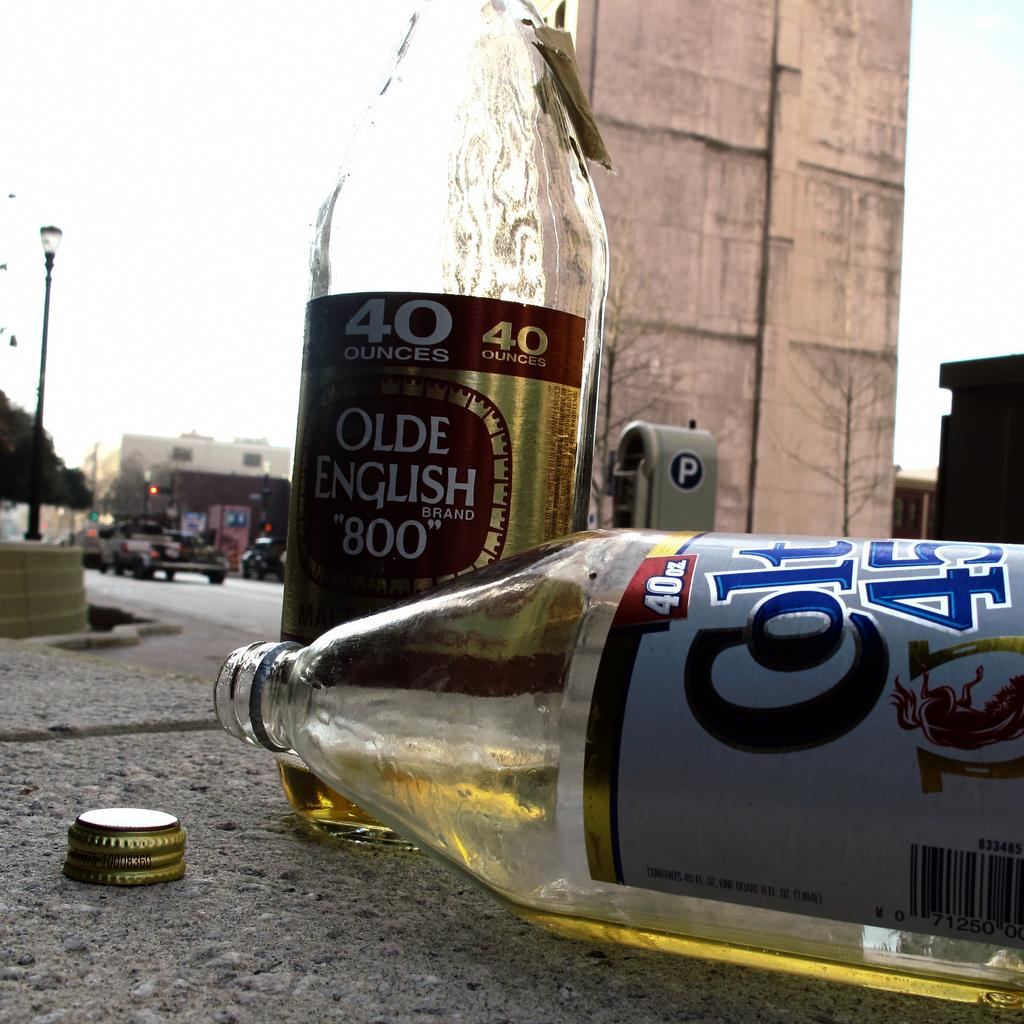<image>
Describe the image concisely. A tilted over glass bottle and another bottle from the Olde English brand. 